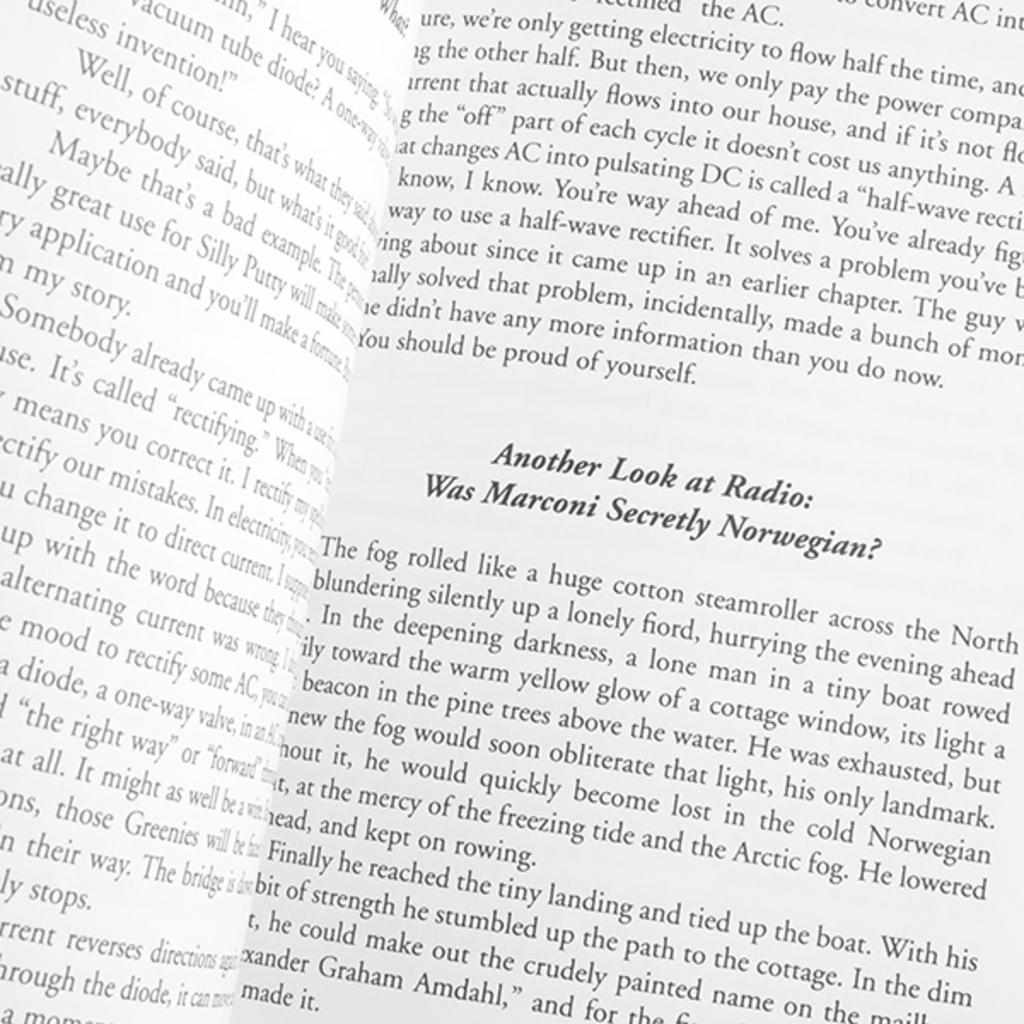What is the first bold word on the page?
Your answer should be very brief. Another. 